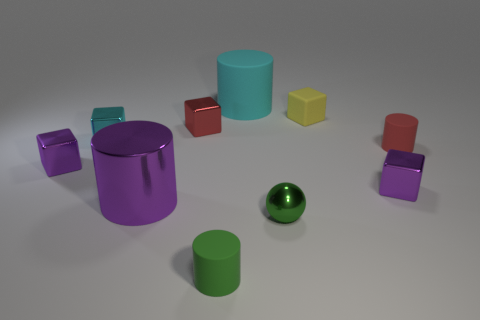The small matte object that is the same color as the sphere is what shape?
Provide a succinct answer. Cylinder. What is the size of the cyan cylinder that is the same material as the yellow object?
Offer a terse response. Large. What number of small cylinders are the same color as the metal ball?
Offer a terse response. 1. What color is the rubber thing that is in front of the cyan cylinder and to the left of the yellow matte object?
Your answer should be compact. Green. What is the big thing that is in front of the tiny red object that is on the right side of the small matte cylinder in front of the red cylinder made of?
Ensure brevity in your answer.  Metal. There is a cube that is to the left of the tiny cyan metallic block; does it have the same color as the large shiny cylinder?
Offer a very short reply. Yes. How many yellow things are either big shiny cylinders or rubber cubes?
Offer a terse response. 1. How many other objects are the same shape as the small green matte object?
Keep it short and to the point. 3. Are the yellow block and the red cube made of the same material?
Offer a very short reply. No. What is the material of the cylinder that is both on the left side of the large cyan matte object and on the right side of the large purple shiny cylinder?
Make the answer very short. Rubber. 